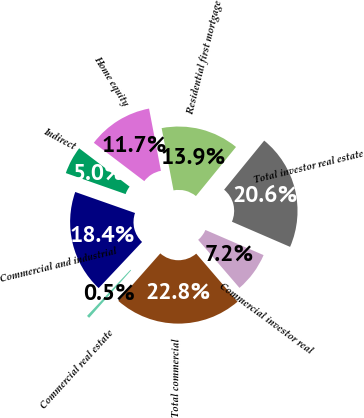Convert chart to OTSL. <chart><loc_0><loc_0><loc_500><loc_500><pie_chart><fcel>Commercial and industrial<fcel>Commercial real estate<fcel>Total commercial<fcel>Commercial investor real<fcel>Total investor real estate<fcel>Residential first mortgage<fcel>Home equity<fcel>Indirect<nl><fcel>18.36%<fcel>0.5%<fcel>22.83%<fcel>7.2%<fcel>20.6%<fcel>13.9%<fcel>11.66%<fcel>4.96%<nl></chart> 